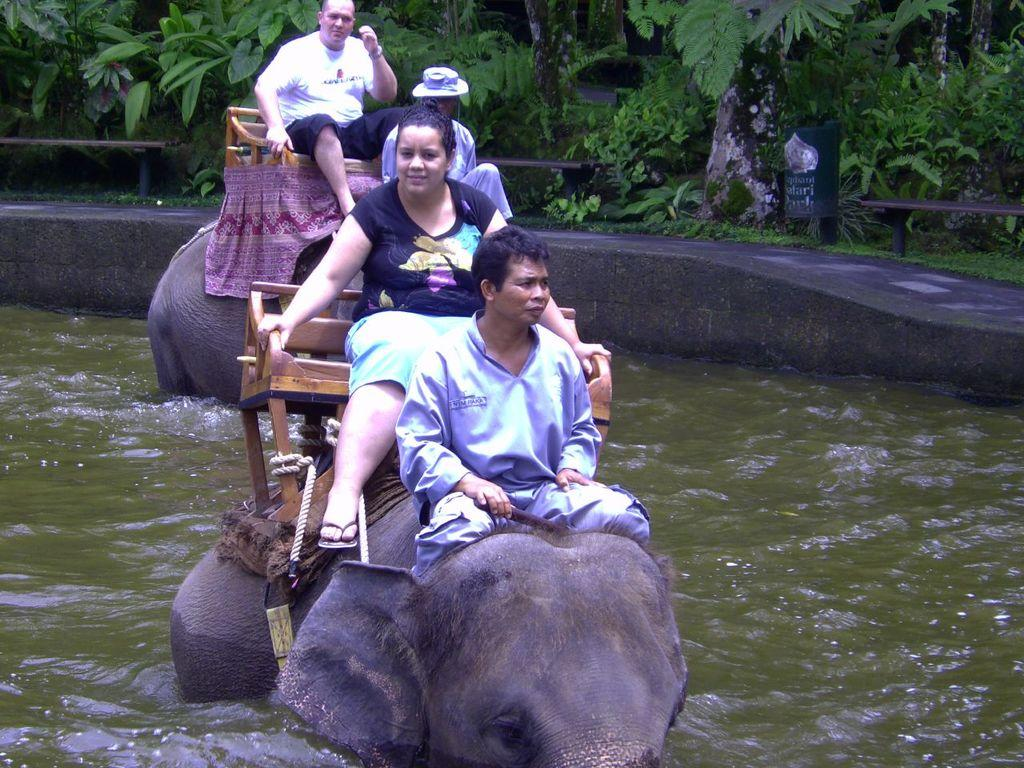What type of living organisms can be seen in the image? Plants can be seen in the image. What are the persons in the image doing? The persons are sitting on elephants. Where are the elephants located in the image? The elephants are inside water. What type of lift is being used by the persons in the image? There is no lift present in the image; the persons are sitting on elephants inside water. What suggestion can be made to improve the harmony between the plants and the elephants in the image? There is no need to make a suggestion to improve harmony, as the image does not depict any interaction between the plants and the elephants. 